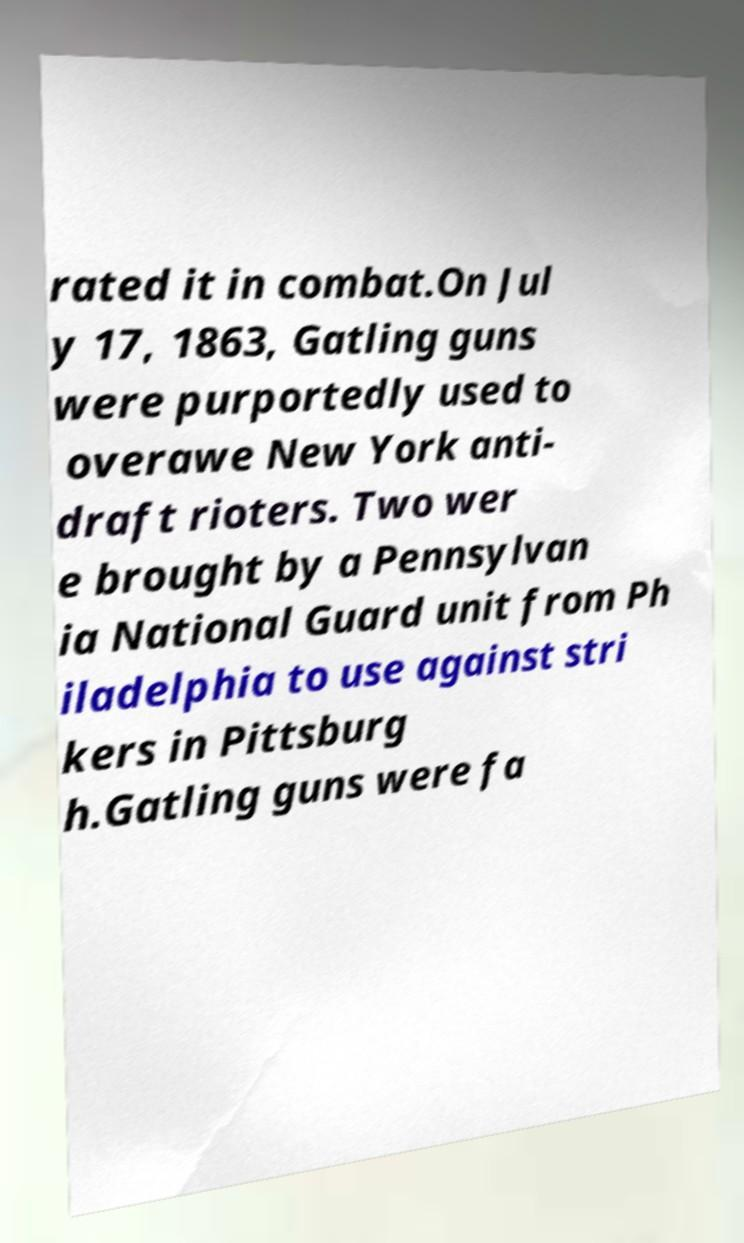What messages or text are displayed in this image? I need them in a readable, typed format. rated it in combat.On Jul y 17, 1863, Gatling guns were purportedly used to overawe New York anti- draft rioters. Two wer e brought by a Pennsylvan ia National Guard unit from Ph iladelphia to use against stri kers in Pittsburg h.Gatling guns were fa 